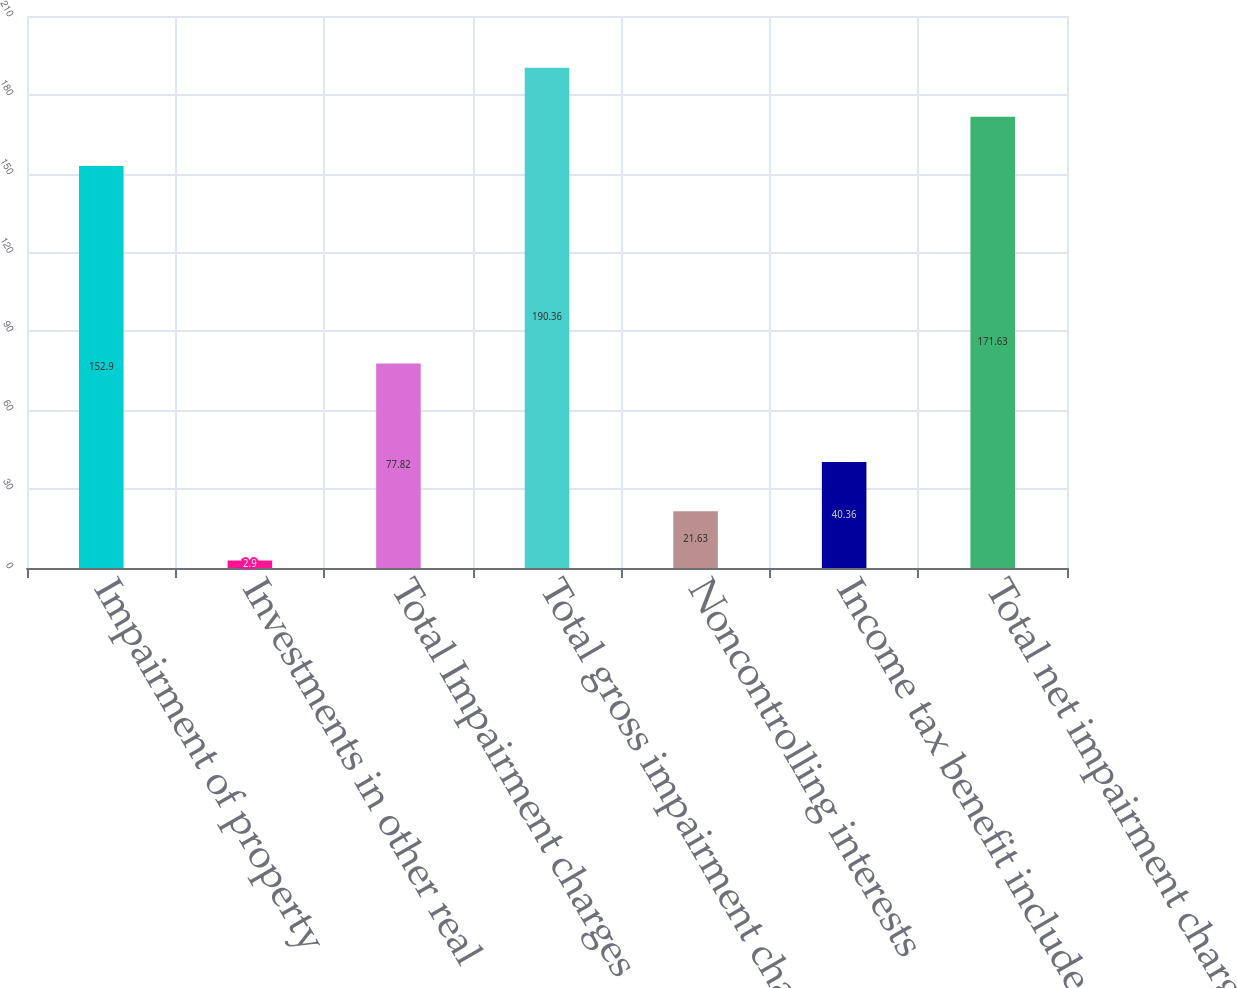Convert chart. <chart><loc_0><loc_0><loc_500><loc_500><bar_chart><fcel>Impairment of property<fcel>Investments in other real<fcel>Total Impairment charges<fcel>Total gross impairment charges<fcel>Noncontrolling interests<fcel>Income tax benefit included in<fcel>Total net impairment charges<nl><fcel>152.9<fcel>2.9<fcel>77.82<fcel>190.36<fcel>21.63<fcel>40.36<fcel>171.63<nl></chart> 